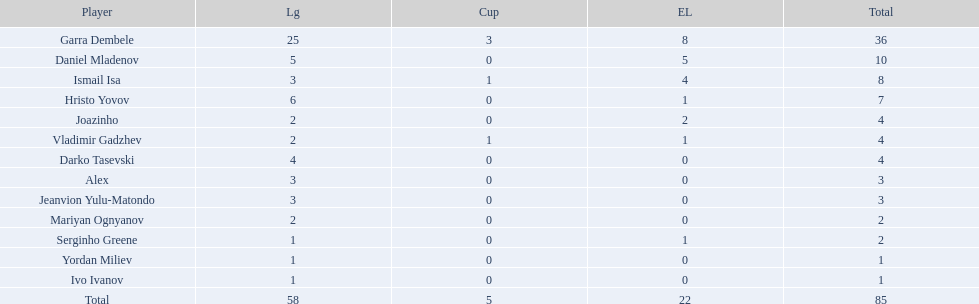What players did not score in all 3 competitions? Daniel Mladenov, Hristo Yovov, Joazinho, Darko Tasevski, Alex, Jeanvion Yulu-Matondo, Mariyan Ognyanov, Serginho Greene, Yordan Miliev, Ivo Ivanov. Which of those did not have total more then 5? Darko Tasevski, Alex, Jeanvion Yulu-Matondo, Mariyan Ognyanov, Serginho Greene, Yordan Miliev, Ivo Ivanov. Which ones scored more then 1 total? Darko Tasevski, Alex, Jeanvion Yulu-Matondo, Mariyan Ognyanov. Which of these player had the lease league points? Mariyan Ognyanov. 